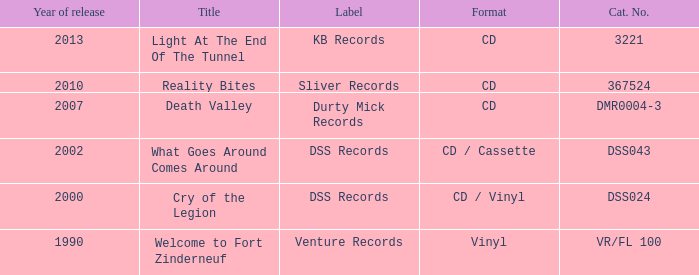In which year was the latest album called death valley released? 2007.0. 